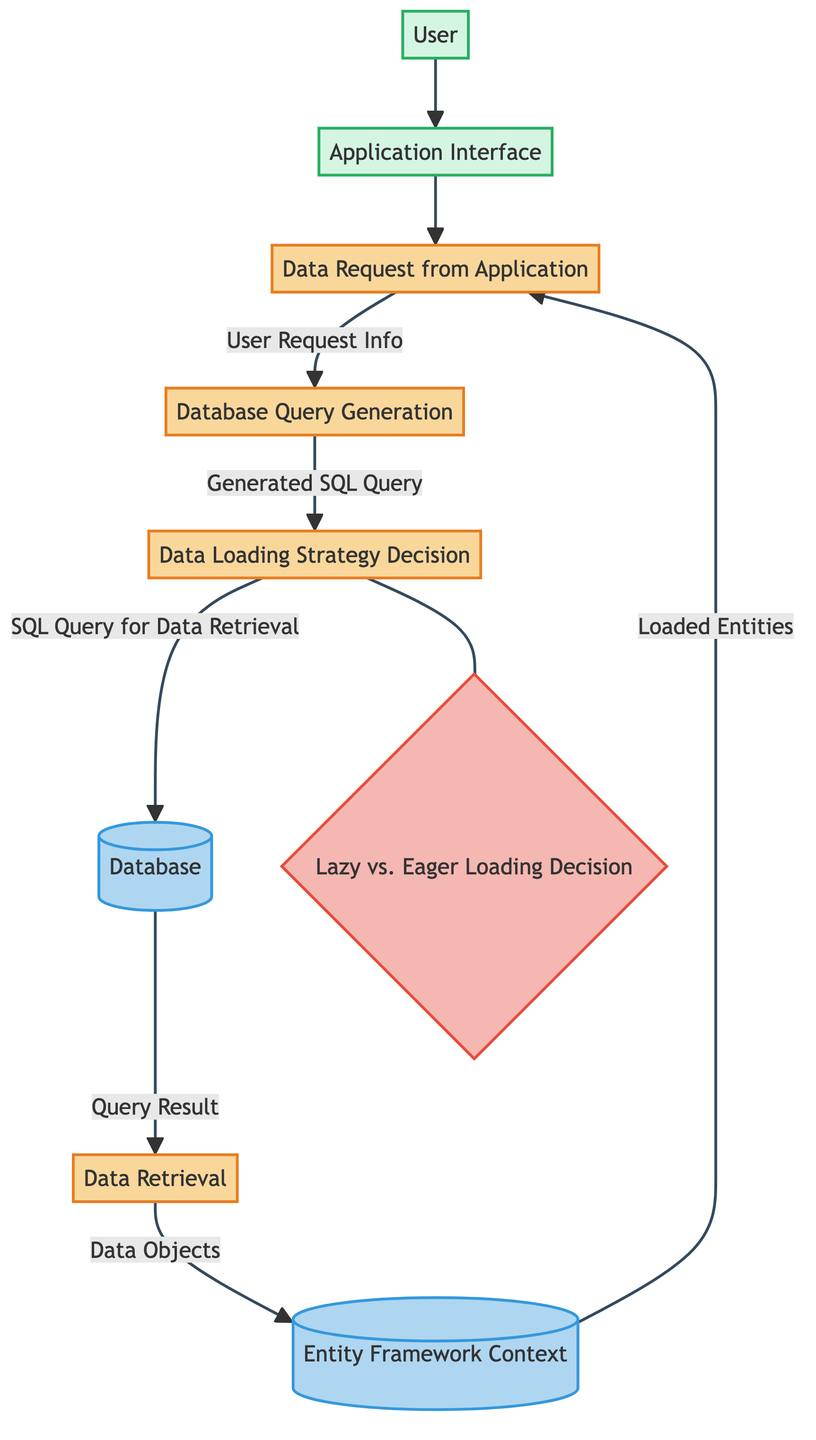What is the first process in the diagram? The diagram starts with the external entity "User," which interacts with the "Application Interface," leading to the "Data Request from Application" process. Hence, the first process is "Data Request from Application."
Answer: Data Request from Application How many processes are represented in the diagram? The diagram contains four distinct processes: "Data Request from Application," "Database Query Generation," "Data Retrieval," and "Data Loading Strategy Decision." Counting these gives a total of four.
Answer: 4 What data flow leads to the database query generation? The flow leading to the "Database Query Generation" process comes from the "Data Request from Application" process, carrying "User Request Info." This indicates what information is passed to generate the SQL query.
Answer: User Request Info What decision point is included in the diagram? The diagram highlights a decision point labeled "Lazy vs. Eager Loading Decision," which indicates a moment where a choice is made on the data loading strategy.
Answer: Lazy vs. Eager Loading Decision How many data stores are present in the diagram? There are two data stores in the diagram: "Entity Framework Context" and "Database." Counting these gives the total number of data stores present in the diagram.
Answer: 2 Which process sends data objects to the Entity Framework context? The process "Data Retrieval" sends "Data Objects" to the "Entity Framework Context." Therefore, this process is responsible for transferring the retrieved data into the context.
Answer: Data Retrieval What is the final output back to the user? The final output sent back to the user is "Loaded Entities," which represents the data returned from the processes for user consumption. This follows the flow from the "Entity Framework Context."
Answer: Loaded Entities What is the relationship between the data retrieval and the database? The "Data Retrieval" process directly queries the "Database" using the "Query Result" output from that database. This indicates that the retrieval process depends on the database to obtain data.
Answer: Query Result From which process is the SQL query for data retrieval generated? The SQL query intended for data retrieval is generated in the "Database Query Generation" process, which receives its input from the preceding "Data Request from Application" process.
Answer: Database Query Generation 